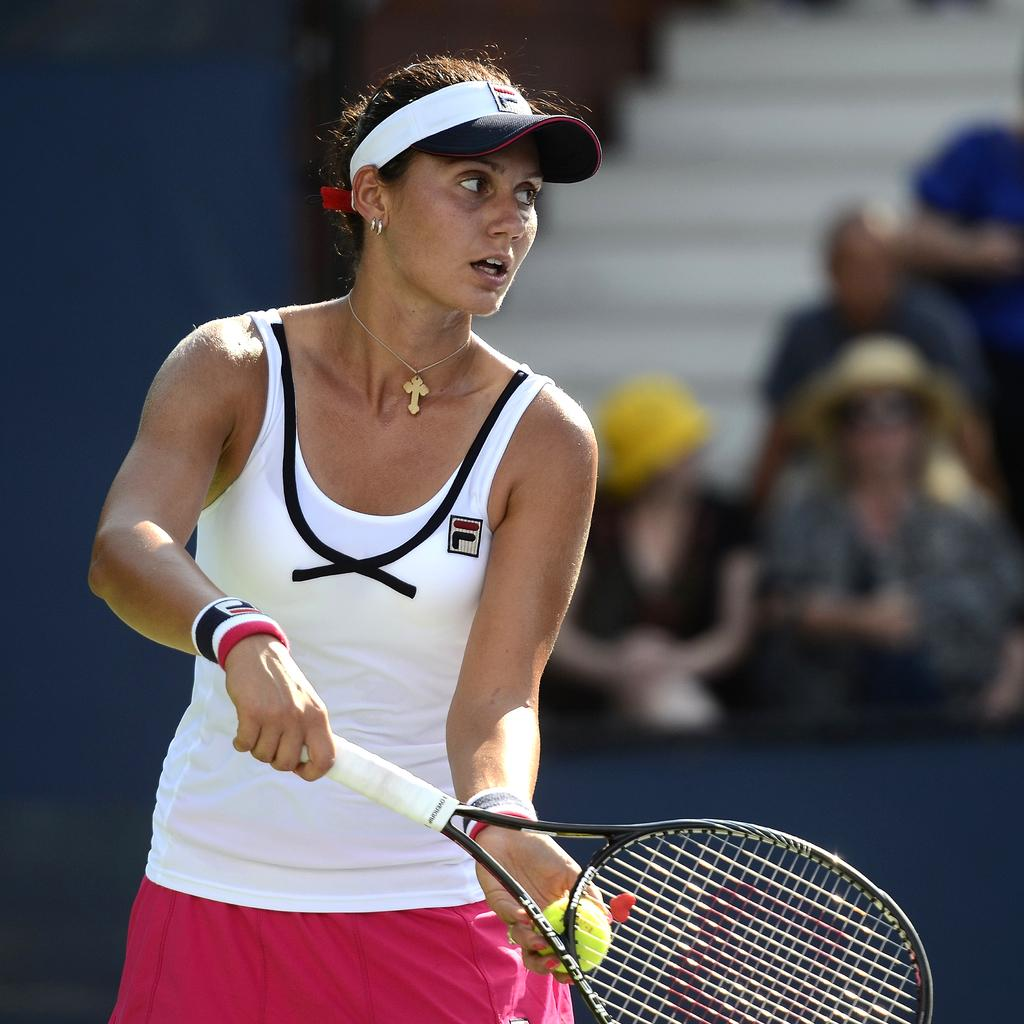Who is the main subject in the image? There is a woman in the image. What is the woman holding in her hands? The woman is holding a racket and a ball. Can you describe the background of the image? There are people in the background of the image. How many houses can be seen in the image? There are no houses visible in the image. What type of hydrant is present in the image? There is no hydrant present in the image. 